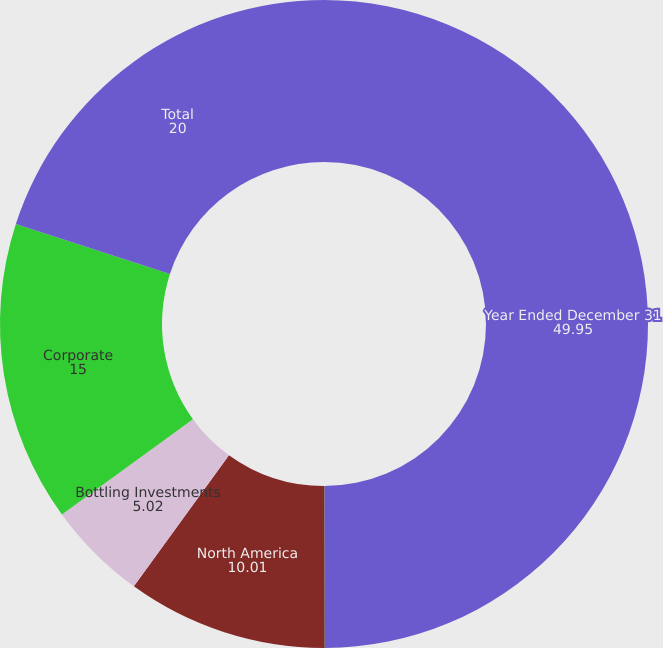<chart> <loc_0><loc_0><loc_500><loc_500><pie_chart><fcel>Year Ended December 31<fcel>Eurasia & Africa<fcel>North America<fcel>Bottling Investments<fcel>Corporate<fcel>Total<nl><fcel>49.95%<fcel>0.02%<fcel>10.01%<fcel>5.02%<fcel>15.0%<fcel>20.0%<nl></chart> 